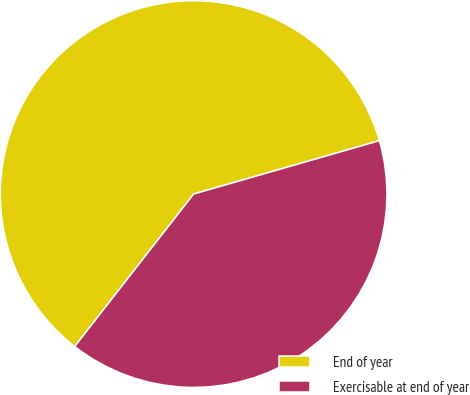Convert chart to OTSL. <chart><loc_0><loc_0><loc_500><loc_500><pie_chart><fcel>End of year<fcel>Exercisable at end of year<nl><fcel>60.0%<fcel>40.0%<nl></chart> 